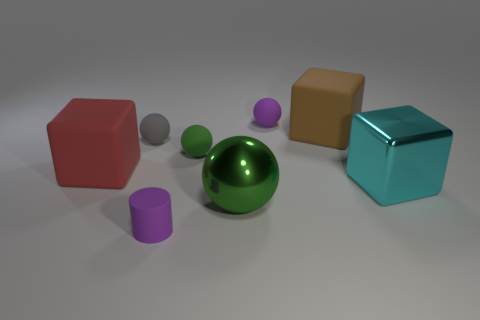Subtract all cylinders. How many objects are left? 7 Add 1 red blocks. How many objects exist? 9 Add 8 big brown objects. How many big brown objects are left? 9 Add 2 tiny yellow matte cylinders. How many tiny yellow matte cylinders exist? 2 Subtract 0 yellow balls. How many objects are left? 8 Subtract all tiny yellow cylinders. Subtract all spheres. How many objects are left? 4 